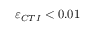Convert formula to latex. <formula><loc_0><loc_0><loc_500><loc_500>\varepsilon _ { C T I } < 0 . 0 1</formula> 